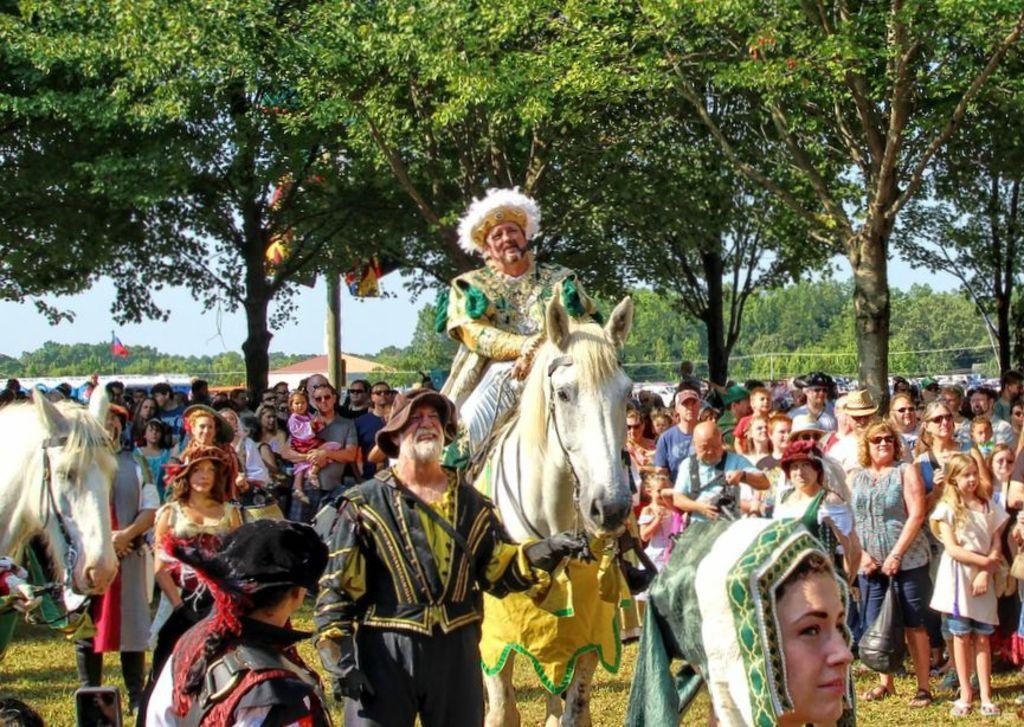Describe this image in one or two sentences. In this image we can see a group of people standing on the ground. We can also see some grass and a person sitting on a horse. On the backside we can see a fence, a group of trees, the flags, a house, poles and the sky which looks cloudy. On the left side we can see a horse. 